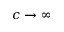<formula> <loc_0><loc_0><loc_500><loc_500>c \to \infty</formula> 